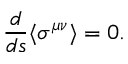Convert formula to latex. <formula><loc_0><loc_0><loc_500><loc_500>\frac { d } { d s } \langle \sigma ^ { \mu \nu } \rangle = 0 .</formula> 